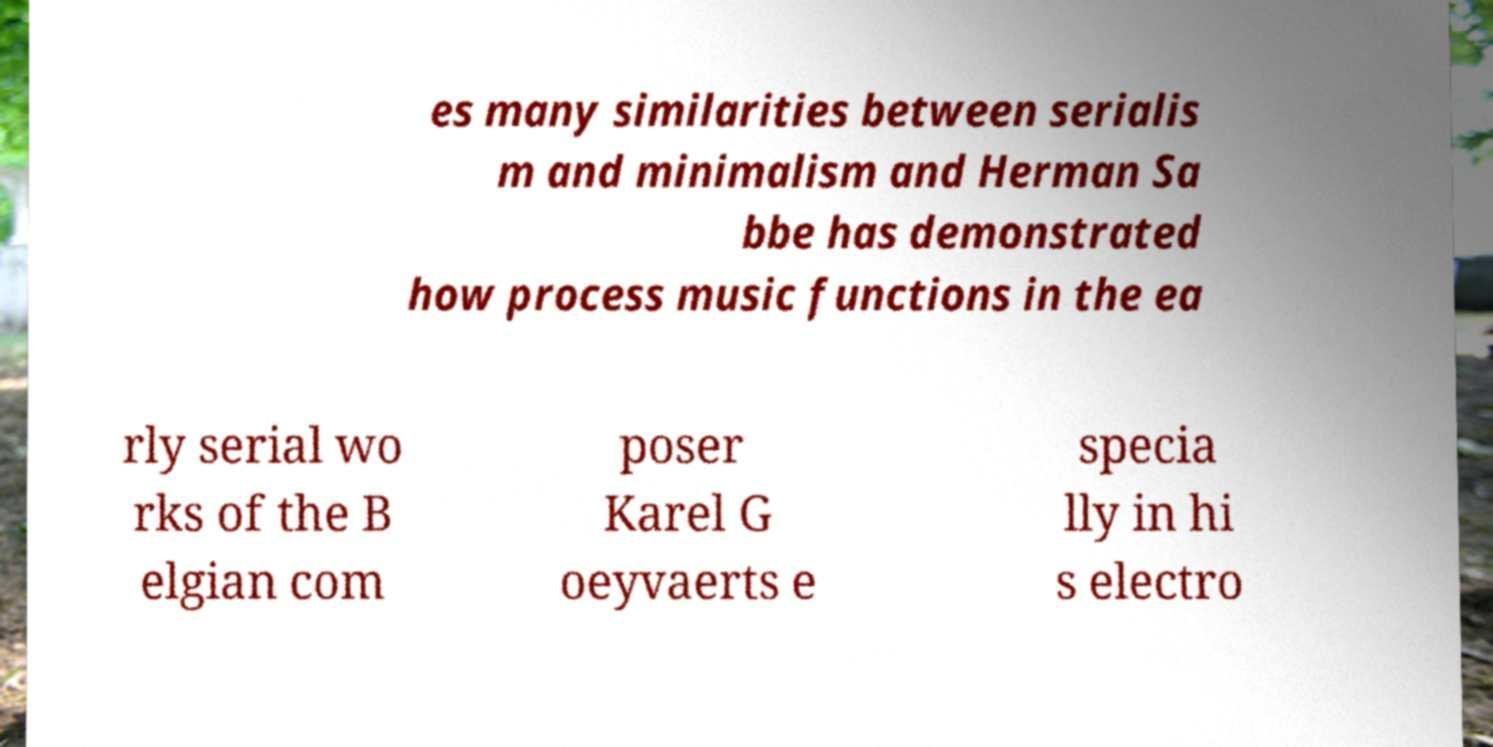Can you accurately transcribe the text from the provided image for me? es many similarities between serialis m and minimalism and Herman Sa bbe has demonstrated how process music functions in the ea rly serial wo rks of the B elgian com poser Karel G oeyvaerts e specia lly in hi s electro 